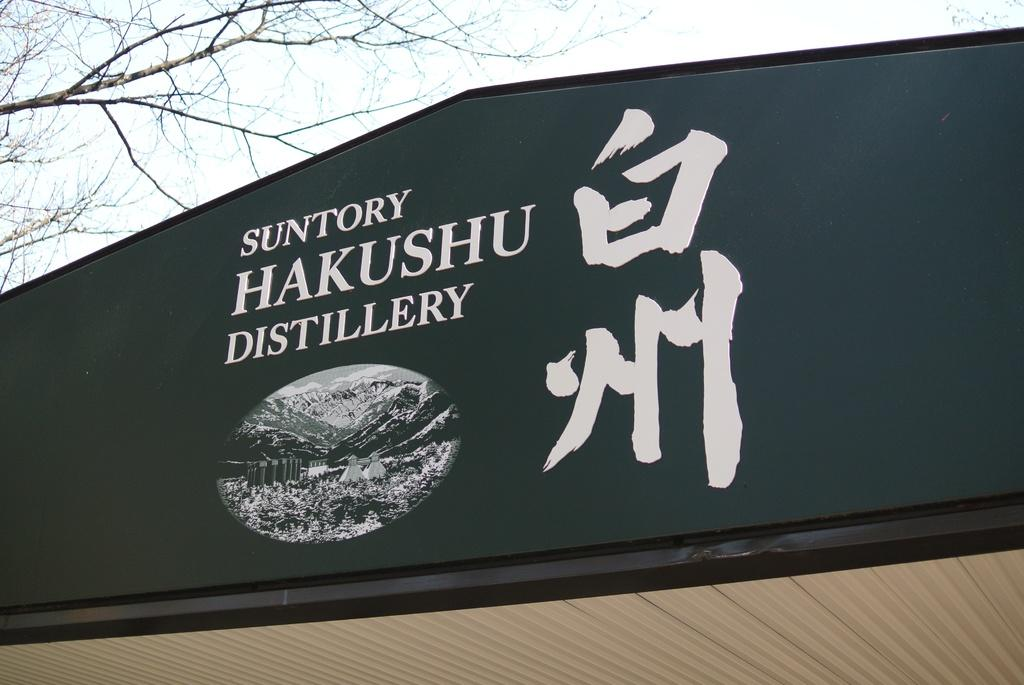What is the main object in the image? There is a name board in the image. What can be seen in the background of the image? The sky is visible in the image. Are there any natural elements present in the image? Yes, there is a tree in the image. How many chickens are present in the image? There are no chickens present in the image. What type of dinner is being served in the image? There is no dinner present in the image. 